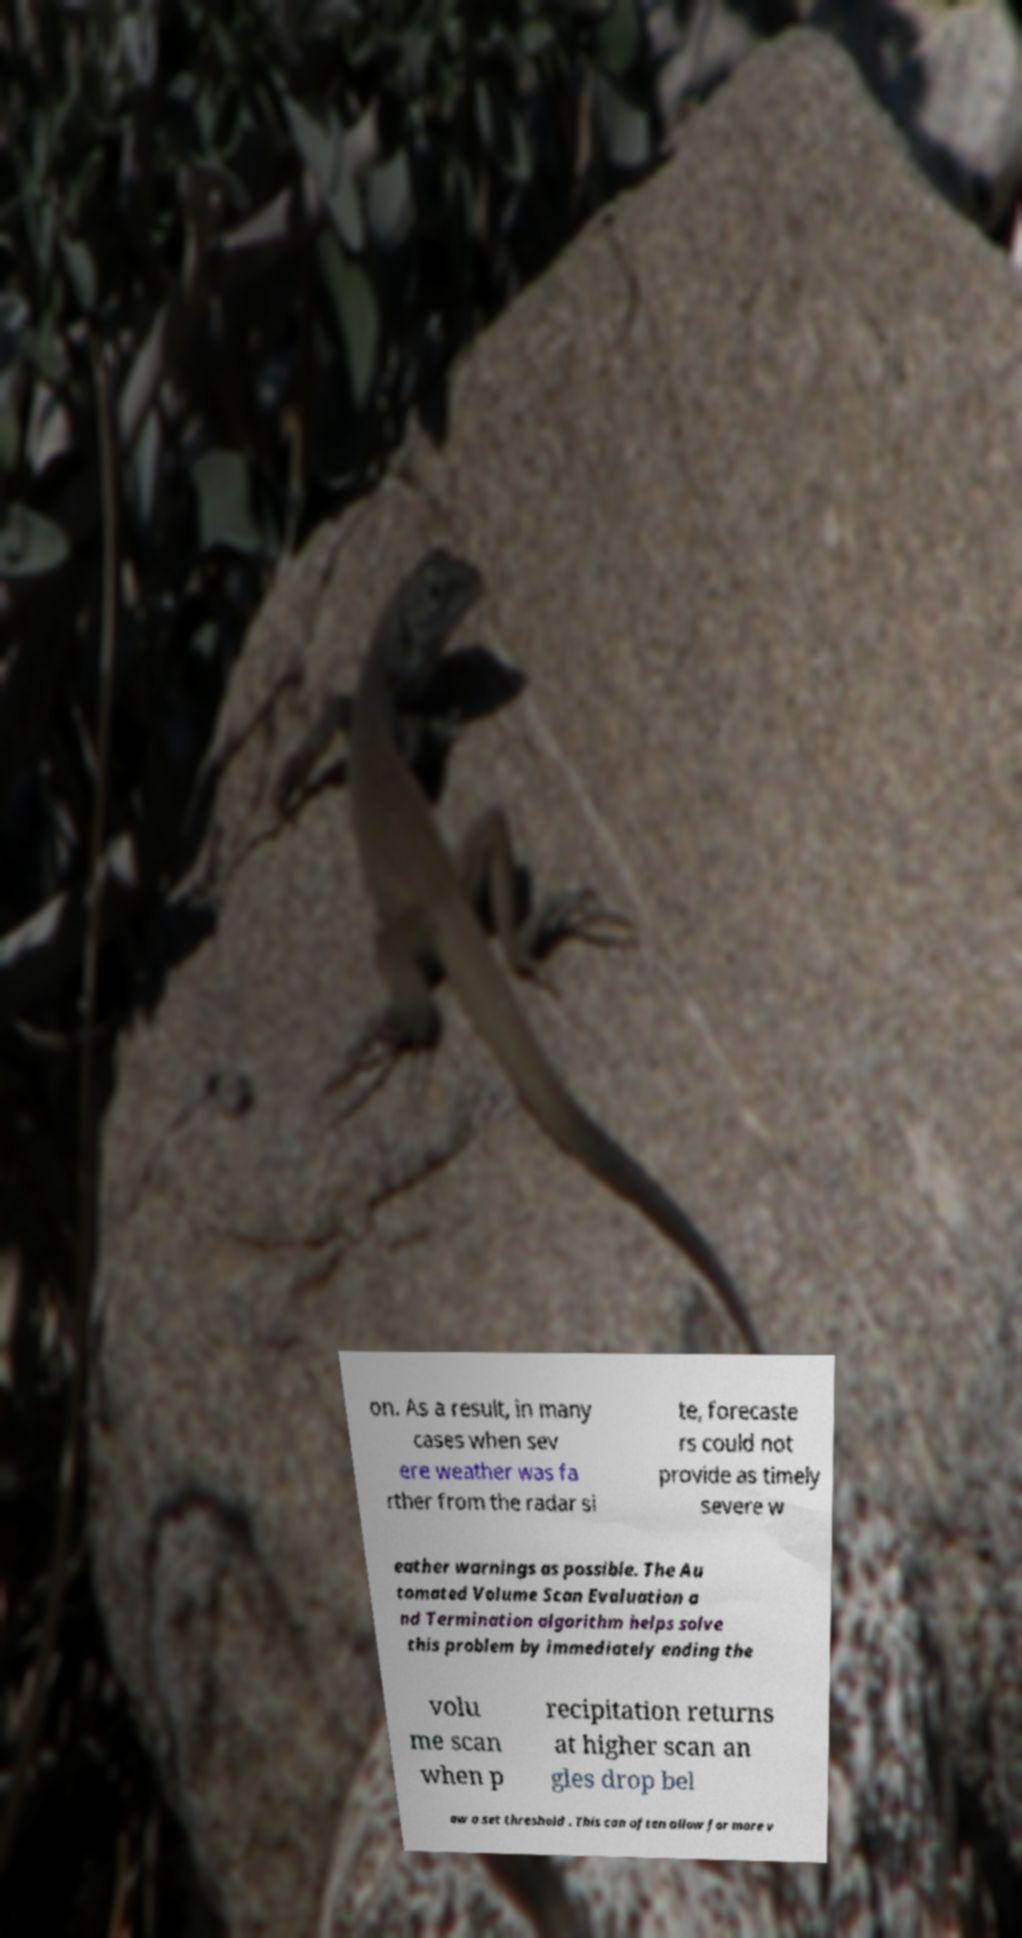Can you read and provide the text displayed in the image?This photo seems to have some interesting text. Can you extract and type it out for me? on. As a result, in many cases when sev ere weather was fa rther from the radar si te, forecaste rs could not provide as timely severe w eather warnings as possible. The Au tomated Volume Scan Evaluation a nd Termination algorithm helps solve this problem by immediately ending the volu me scan when p recipitation returns at higher scan an gles drop bel ow a set threshold . This can often allow for more v 